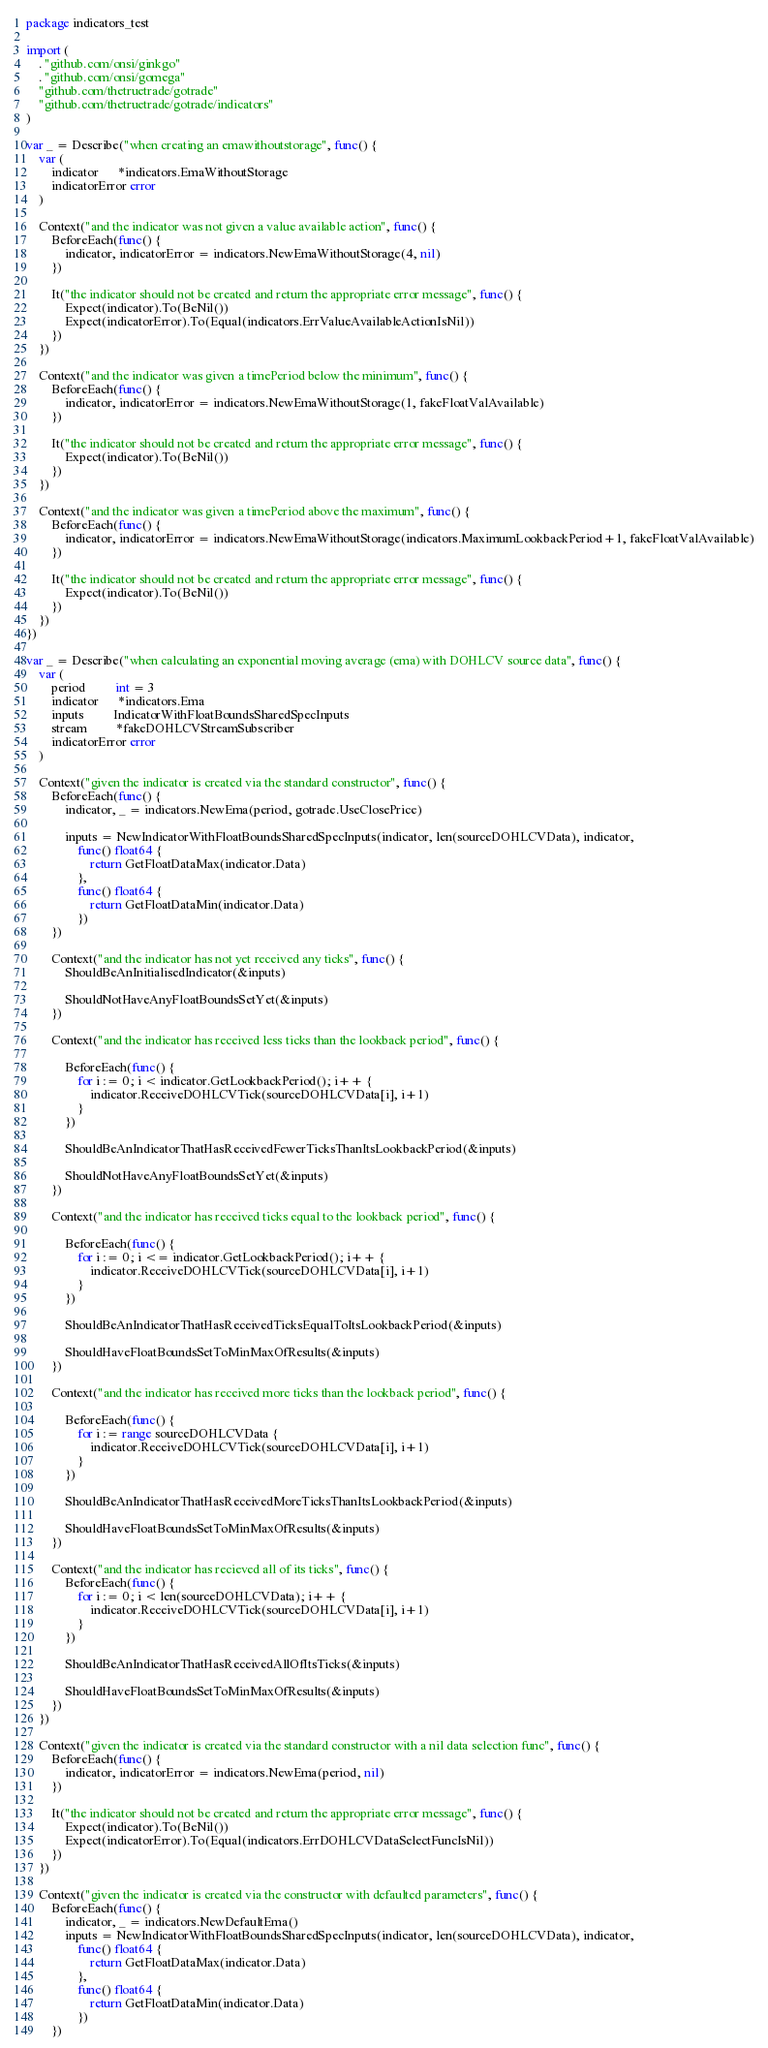<code> <loc_0><loc_0><loc_500><loc_500><_Go_>package indicators_test

import (
	. "github.com/onsi/ginkgo"
	. "github.com/onsi/gomega"
	"github.com/thetruetrade/gotrade"
	"github.com/thetruetrade/gotrade/indicators"
)

var _ = Describe("when creating an emawithoutstorage", func() {
	var (
		indicator      *indicators.EmaWithoutStorage
		indicatorError error
	)

	Context("and the indicator was not given a value available action", func() {
		BeforeEach(func() {
			indicator, indicatorError = indicators.NewEmaWithoutStorage(4, nil)
		})

		It("the indicator should not be created and return the appropriate error message", func() {
			Expect(indicator).To(BeNil())
			Expect(indicatorError).To(Equal(indicators.ErrValueAvailableActionIsNil))
		})
	})

	Context("and the indicator was given a timePeriod below the minimum", func() {
		BeforeEach(func() {
			indicator, indicatorError = indicators.NewEmaWithoutStorage(1, fakeFloatValAvailable)
		})

		It("the indicator should not be created and return the appropriate error message", func() {
			Expect(indicator).To(BeNil())
		})
	})

	Context("and the indicator was given a timePeriod above the maximum", func() {
		BeforeEach(func() {
			indicator, indicatorError = indicators.NewEmaWithoutStorage(indicators.MaximumLookbackPeriod+1, fakeFloatValAvailable)
		})

		It("the indicator should not be created and return the appropriate error message", func() {
			Expect(indicator).To(BeNil())
		})
	})
})

var _ = Describe("when calculating an exponential moving average (ema) with DOHLCV source data", func() {
	var (
		period         int = 3
		indicator      *indicators.Ema
		inputs         IndicatorWithFloatBoundsSharedSpecInputs
		stream         *fakeDOHLCVStreamSubscriber
		indicatorError error
	)

	Context("given the indicator is created via the standard constructor", func() {
		BeforeEach(func() {
			indicator, _ = indicators.NewEma(period, gotrade.UseClosePrice)

			inputs = NewIndicatorWithFloatBoundsSharedSpecInputs(indicator, len(sourceDOHLCVData), indicator,
				func() float64 {
					return GetFloatDataMax(indicator.Data)
				},
				func() float64 {
					return GetFloatDataMin(indicator.Data)
				})
		})

		Context("and the indicator has not yet received any ticks", func() {
			ShouldBeAnInitialisedIndicator(&inputs)

			ShouldNotHaveAnyFloatBoundsSetYet(&inputs)
		})

		Context("and the indicator has received less ticks than the lookback period", func() {

			BeforeEach(func() {
				for i := 0; i < indicator.GetLookbackPeriod(); i++ {
					indicator.ReceiveDOHLCVTick(sourceDOHLCVData[i], i+1)
				}
			})

			ShouldBeAnIndicatorThatHasReceivedFewerTicksThanItsLookbackPeriod(&inputs)

			ShouldNotHaveAnyFloatBoundsSetYet(&inputs)
		})

		Context("and the indicator has received ticks equal to the lookback period", func() {

			BeforeEach(func() {
				for i := 0; i <= indicator.GetLookbackPeriod(); i++ {
					indicator.ReceiveDOHLCVTick(sourceDOHLCVData[i], i+1)
				}
			})

			ShouldBeAnIndicatorThatHasReceivedTicksEqualToItsLookbackPeriod(&inputs)

			ShouldHaveFloatBoundsSetToMinMaxOfResults(&inputs)
		})

		Context("and the indicator has received more ticks than the lookback period", func() {

			BeforeEach(func() {
				for i := range sourceDOHLCVData {
					indicator.ReceiveDOHLCVTick(sourceDOHLCVData[i], i+1)
				}
			})

			ShouldBeAnIndicatorThatHasReceivedMoreTicksThanItsLookbackPeriod(&inputs)

			ShouldHaveFloatBoundsSetToMinMaxOfResults(&inputs)
		})

		Context("and the indicator has recieved all of its ticks", func() {
			BeforeEach(func() {
				for i := 0; i < len(sourceDOHLCVData); i++ {
					indicator.ReceiveDOHLCVTick(sourceDOHLCVData[i], i+1)
				}
			})

			ShouldBeAnIndicatorThatHasReceivedAllOfItsTicks(&inputs)

			ShouldHaveFloatBoundsSetToMinMaxOfResults(&inputs)
		})
	})

	Context("given the indicator is created via the standard constructor with a nil data selection func", func() {
		BeforeEach(func() {
			indicator, indicatorError = indicators.NewEma(period, nil)
		})

		It("the indicator should not be created and return the appropriate error message", func() {
			Expect(indicator).To(BeNil())
			Expect(indicatorError).To(Equal(indicators.ErrDOHLCVDataSelectFuncIsNil))
		})
	})

	Context("given the indicator is created via the constructor with defaulted parameters", func() {
		BeforeEach(func() {
			indicator, _ = indicators.NewDefaultEma()
			inputs = NewIndicatorWithFloatBoundsSharedSpecInputs(indicator, len(sourceDOHLCVData), indicator,
				func() float64 {
					return GetFloatDataMax(indicator.Data)
				},
				func() float64 {
					return GetFloatDataMin(indicator.Data)
				})
		})
</code> 